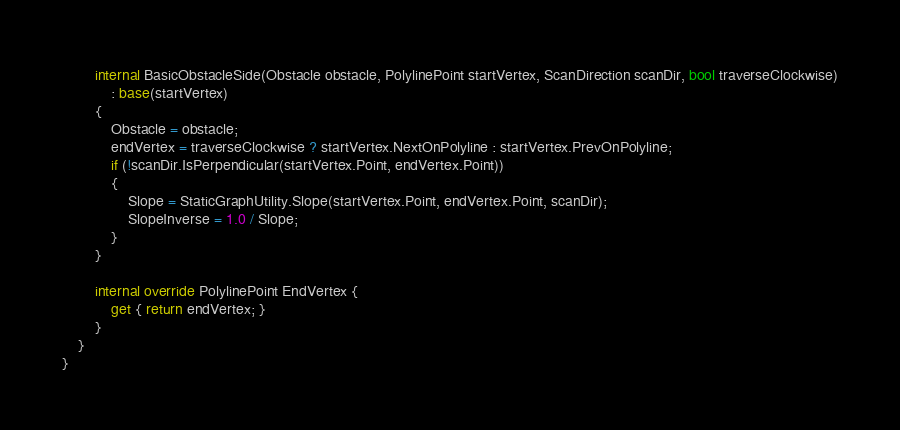Convert code to text. <code><loc_0><loc_0><loc_500><loc_500><_C#_>        internal BasicObstacleSide(Obstacle obstacle, PolylinePoint startVertex, ScanDirection scanDir, bool traverseClockwise)
            : base(startVertex)
        {
            Obstacle = obstacle;
            endVertex = traverseClockwise ? startVertex.NextOnPolyline : startVertex.PrevOnPolyline;
            if (!scanDir.IsPerpendicular(startVertex.Point, endVertex.Point))
            {
                Slope = StaticGraphUtility.Slope(startVertex.Point, endVertex.Point, scanDir);
                SlopeInverse = 1.0 / Slope;
            }
        }
        
        internal override PolylinePoint EndVertex {
            get { return endVertex; }
        }
    }
}
</code> 